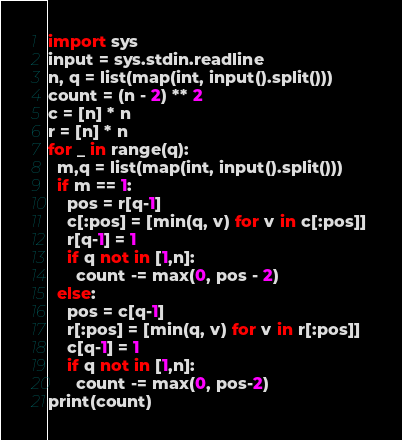Convert code to text. <code><loc_0><loc_0><loc_500><loc_500><_Python_>import sys
input = sys.stdin.readline
n, q = list(map(int, input().split()))
count = (n - 2) ** 2
c = [n] * n
r = [n] * n
for _ in range(q):
  m,q = list(map(int, input().split()))
  if m == 1:
    pos = r[q-1]
    c[:pos] = [min(q, v) for v in c[:pos]] 
    r[q-1] = 1
    if q not in [1,n]:
      count -= max(0, pos - 2)
  else:
    pos = c[q-1]
    r[:pos] = [min(q, v) for v in r[:pos]]
    c[q-1] = 1
    if q not in [1,n]:
      count -= max(0, pos-2)
print(count)</code> 